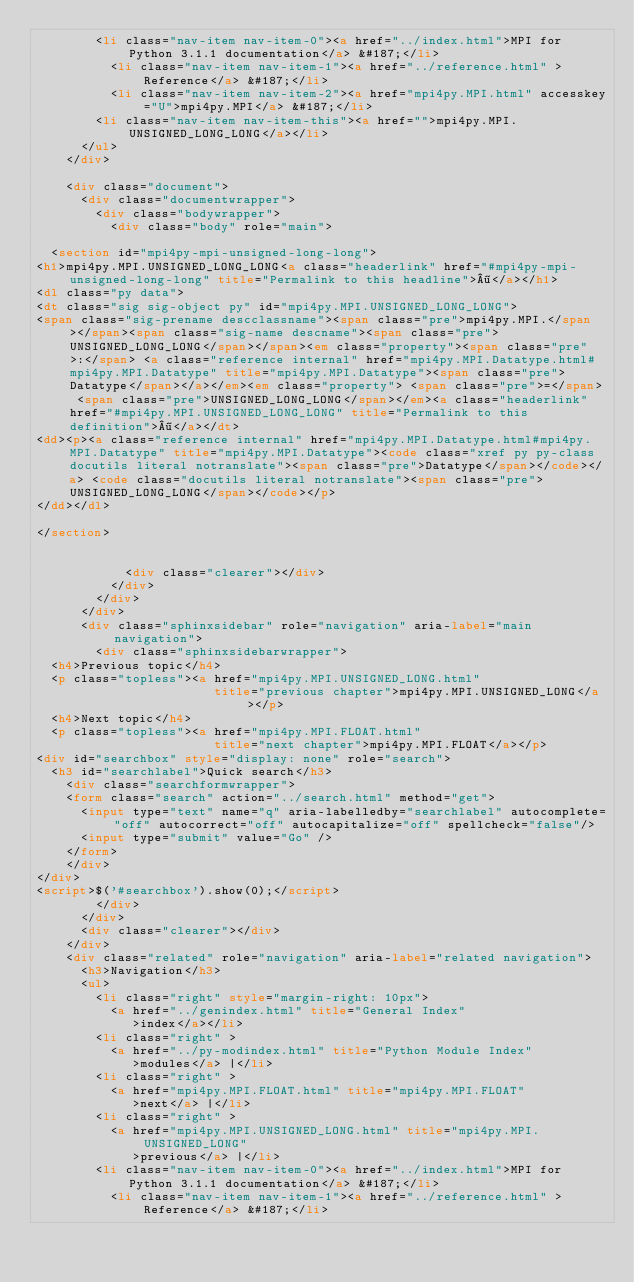Convert code to text. <code><loc_0><loc_0><loc_500><loc_500><_HTML_>        <li class="nav-item nav-item-0"><a href="../index.html">MPI for Python 3.1.1 documentation</a> &#187;</li>
          <li class="nav-item nav-item-1"><a href="../reference.html" >Reference</a> &#187;</li>
          <li class="nav-item nav-item-2"><a href="mpi4py.MPI.html" accesskey="U">mpi4py.MPI</a> &#187;</li>
        <li class="nav-item nav-item-this"><a href="">mpi4py.MPI.UNSIGNED_LONG_LONG</a></li> 
      </ul>
    </div>  

    <div class="document">
      <div class="documentwrapper">
        <div class="bodywrapper">
          <div class="body" role="main">
            
  <section id="mpi4py-mpi-unsigned-long-long">
<h1>mpi4py.MPI.UNSIGNED_LONG_LONG<a class="headerlink" href="#mpi4py-mpi-unsigned-long-long" title="Permalink to this headline">¶</a></h1>
<dl class="py data">
<dt class="sig sig-object py" id="mpi4py.MPI.UNSIGNED_LONG_LONG">
<span class="sig-prename descclassname"><span class="pre">mpi4py.MPI.</span></span><span class="sig-name descname"><span class="pre">UNSIGNED_LONG_LONG</span></span><em class="property"><span class="pre">:</span> <a class="reference internal" href="mpi4py.MPI.Datatype.html#mpi4py.MPI.Datatype" title="mpi4py.MPI.Datatype"><span class="pre">Datatype</span></a></em><em class="property"> <span class="pre">=</span> <span class="pre">UNSIGNED_LONG_LONG</span></em><a class="headerlink" href="#mpi4py.MPI.UNSIGNED_LONG_LONG" title="Permalink to this definition">¶</a></dt>
<dd><p><a class="reference internal" href="mpi4py.MPI.Datatype.html#mpi4py.MPI.Datatype" title="mpi4py.MPI.Datatype"><code class="xref py py-class docutils literal notranslate"><span class="pre">Datatype</span></code></a> <code class="docutils literal notranslate"><span class="pre">UNSIGNED_LONG_LONG</span></code></p>
</dd></dl>

</section>


            <div class="clearer"></div>
          </div>
        </div>
      </div>
      <div class="sphinxsidebar" role="navigation" aria-label="main navigation">
        <div class="sphinxsidebarwrapper">
  <h4>Previous topic</h4>
  <p class="topless"><a href="mpi4py.MPI.UNSIGNED_LONG.html"
                        title="previous chapter">mpi4py.MPI.UNSIGNED_LONG</a></p>
  <h4>Next topic</h4>
  <p class="topless"><a href="mpi4py.MPI.FLOAT.html"
                        title="next chapter">mpi4py.MPI.FLOAT</a></p>
<div id="searchbox" style="display: none" role="search">
  <h3 id="searchlabel">Quick search</h3>
    <div class="searchformwrapper">
    <form class="search" action="../search.html" method="get">
      <input type="text" name="q" aria-labelledby="searchlabel" autocomplete="off" autocorrect="off" autocapitalize="off" spellcheck="false"/>
      <input type="submit" value="Go" />
    </form>
    </div>
</div>
<script>$('#searchbox').show(0);</script>
        </div>
      </div>
      <div class="clearer"></div>
    </div>
    <div class="related" role="navigation" aria-label="related navigation">
      <h3>Navigation</h3>
      <ul>
        <li class="right" style="margin-right: 10px">
          <a href="../genindex.html" title="General Index"
             >index</a></li>
        <li class="right" >
          <a href="../py-modindex.html" title="Python Module Index"
             >modules</a> |</li>
        <li class="right" >
          <a href="mpi4py.MPI.FLOAT.html" title="mpi4py.MPI.FLOAT"
             >next</a> |</li>
        <li class="right" >
          <a href="mpi4py.MPI.UNSIGNED_LONG.html" title="mpi4py.MPI.UNSIGNED_LONG"
             >previous</a> |</li>
        <li class="nav-item nav-item-0"><a href="../index.html">MPI for Python 3.1.1 documentation</a> &#187;</li>
          <li class="nav-item nav-item-1"><a href="../reference.html" >Reference</a> &#187;</li></code> 